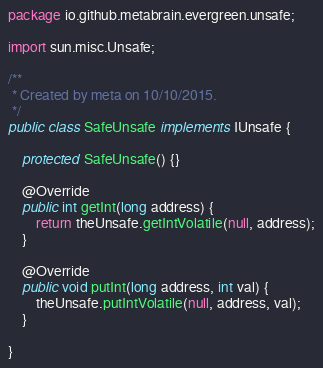<code> <loc_0><loc_0><loc_500><loc_500><_Java_>package io.github.metabrain.evergreen.unsafe;

import sun.misc.Unsafe;

/**
 * Created by meta on 10/10/2015.
 */
public class SafeUnsafe implements IUnsafe {

    protected SafeUnsafe() {}

    @Override
    public int getInt(long address) {
        return theUnsafe.getIntVolatile(null, address);
    }

    @Override
    public void putInt(long address, int val) {
        theUnsafe.putIntVolatile(null, address, val);
    }

}
</code> 